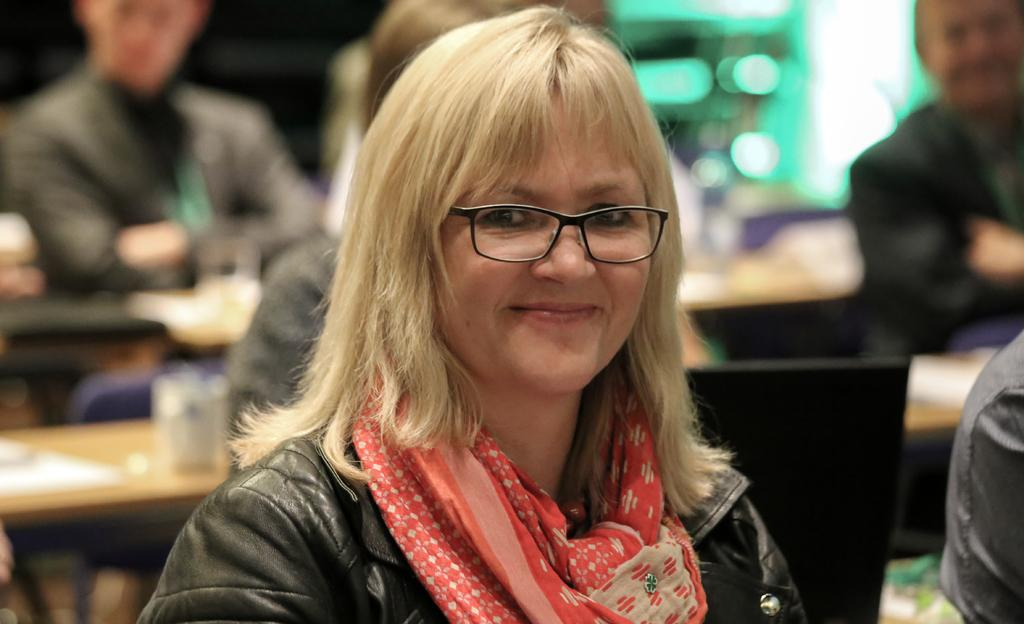Who is present in the image? There is a woman in the image. What is the woman doing in the image? The woman is smiling in the image. What accessory is the woman wearing? The woman is wearing spectacles in the image. Can you describe the background of the image? The background of the image is blurry. What else can be seen in the background? There are people and objects on tables visible in the background. What type of corn is being harvested in the image? There is no corn present in the image; it features a woman smiling and wearing spectacles. Is the woman wearing a veil in the image? No, the woman is not wearing a veil in the image; she is wearing spectacles. 